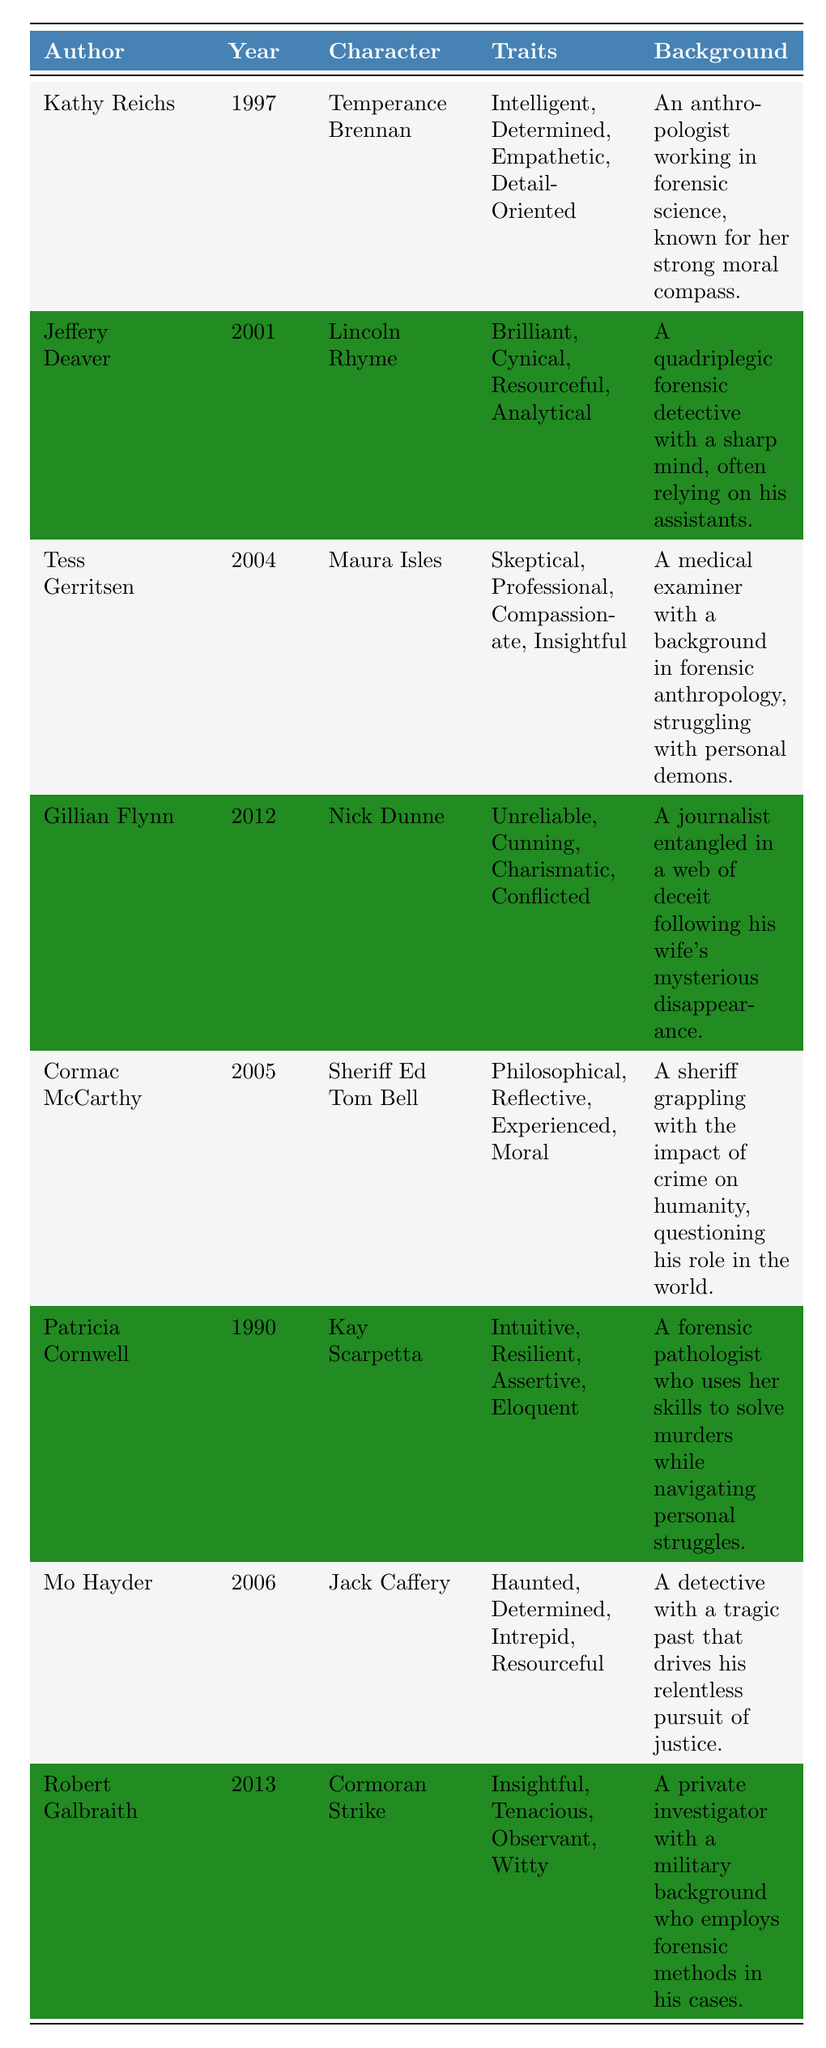What year was "Kay Scarpetta" published? The table lists Patricia Cornwell as the author of the character Kay Scarpetta, with a publication year of 1990.
Answer: 1990 Which character is described as "Cynical"? The table indicates that Lincoln Rhyme, created by Jeffery Deaver in 2001, has "Cynical" among his traits.
Answer: Lincoln Rhyme How many characters are listed between the years 1990 and 2005? The characters listed in this range are Kay Scarpetta (1990), Sheriff Ed Tom Bell (2005), and Temperance Brennan (1997), resulting in a total of 3 characters.
Answer: 3 Is "Resourceful" a trait of any character? Yes, the table shows that both Lincoln Rhyme and Jack Caffery have "Resourceful" listed as one of their traits.
Answer: Yes Which author created a character characterized as "Haunted"? The author who created the character described as "Haunted" is Mo Hayder, with the character being Jack Caffery, published in 2006.
Answer: Mo Hayder What are the traits of the character from the earliest publication year? The earliest publication year is 1990 for Kay Scarpetta, whose traits are Intuitive, Resilient, Assertive, and Eloquent.
Answer: Intuitive, Resilient, Assertive, Eloquent Which character has the most complex background description based on the provided information? Nick Dunne has a background involving a web of deceit regarding his wife’s mysterious disappearance, making it complex compared to others.
Answer: Nick Dunne Is there a character that has a background related to military service? Yes, Cormoran Strike has a military background as stated in the character's background information in the table.
Answer: Yes Which character's traits include "Compassionate"? The character Maura Isles, created by Tess Gerritsen in 2004, has "Compassionate" listed among her traits.
Answer: Maura Isles How many characters share the trait "Determined"? Two characters share this trait: Temperance Brennan and Jack Caffery, both of whom are depicted as "Determined".
Answer: 2 What is the publication year of the character with the trait "Witty"? The character Cormoran Strike exhibits the trait "Witty", which is associated with the publication year of 2013.
Answer: 2013 